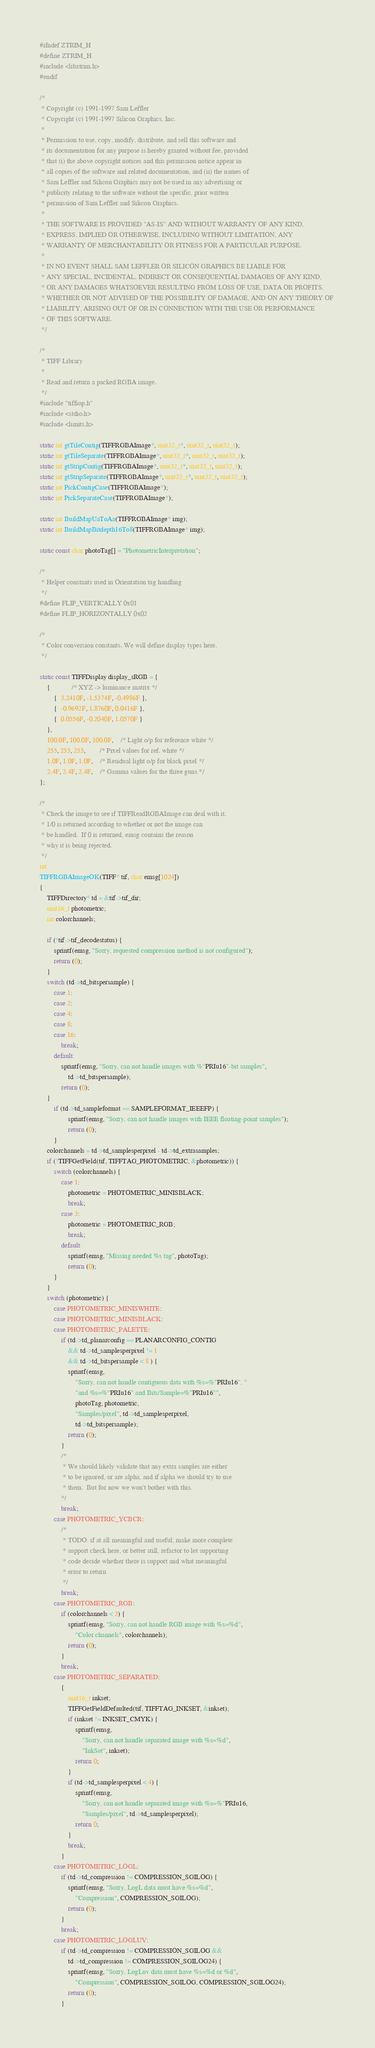<code> <loc_0><loc_0><loc_500><loc_500><_C_>#ifndef ZTRIM_H
#define ZTRIM_H
#include <libztrim.h>
#endif

/*
 * Copyright (c) 1991-1997 Sam Leffler
 * Copyright (c) 1991-1997 Silicon Graphics, Inc.
 *
 * Permission to use, copy, modify, distribute, and sell this software and 
 * its documentation for any purpose is hereby granted without fee, provided
 * that (i) the above copyright notices and this permission notice appear in
 * all copies of the software and related documentation, and (ii) the names of
 * Sam Leffler and Silicon Graphics may not be used in any advertising or
 * publicity relating to the software without the specific, prior written
 * permission of Sam Leffler and Silicon Graphics.
 * 
 * THE SOFTWARE IS PROVIDED "AS-IS" AND WITHOUT WARRANTY OF ANY KIND, 
 * EXPRESS, IMPLIED OR OTHERWISE, INCLUDING WITHOUT LIMITATION, ANY 
 * WARRANTY OF MERCHANTABILITY OR FITNESS FOR A PARTICULAR PURPOSE.  
 * 
 * IN NO EVENT SHALL SAM LEFFLER OR SILICON GRAPHICS BE LIABLE FOR
 * ANY SPECIAL, INCIDENTAL, INDIRECT OR CONSEQUENTIAL DAMAGES OF ANY KIND,
 * OR ANY DAMAGES WHATSOEVER RESULTING FROM LOSS OF USE, DATA OR PROFITS,
 * WHETHER OR NOT ADVISED OF THE POSSIBILITY OF DAMAGE, AND ON ANY THEORY OF 
 * LIABILITY, ARISING OUT OF OR IN CONNECTION WITH THE USE OR PERFORMANCE 
 * OF THIS SOFTWARE.
 */

/*
 * TIFF Library
 *
 * Read and return a packed RGBA image.
 */
#include "tiffiop.h"
#include <stdio.h>
#include <limits.h>

static int gtTileContig(TIFFRGBAImage*, uint32_t*, uint32_t, uint32_t);
static int gtTileSeparate(TIFFRGBAImage*, uint32_t*, uint32_t, uint32_t);
static int gtStripContig(TIFFRGBAImage*, uint32_t*, uint32_t, uint32_t);
static int gtStripSeparate(TIFFRGBAImage*, uint32_t*, uint32_t, uint32_t);
static int PickContigCase(TIFFRGBAImage*);
static int PickSeparateCase(TIFFRGBAImage*);

static int BuildMapUaToAa(TIFFRGBAImage* img);
static int BuildMapBitdepth16To8(TIFFRGBAImage* img);

static const char photoTag[] = "PhotometricInterpretation";

/* 
 * Helper constants used in Orientation tag handling
 */
#define FLIP_VERTICALLY 0x01
#define FLIP_HORIZONTALLY 0x02

/*
 * Color conversion constants. We will define display types here.
 */

static const TIFFDisplay display_sRGB = {
	{			/* XYZ -> luminance matrix */
		{  3.2410F, -1.5374F, -0.4986F },
		{  -0.9692F, 1.8760F, 0.0416F },
		{  0.0556F, -0.2040F, 1.0570F }
	},	
	100.0F, 100.0F, 100.0F,	/* Light o/p for reference white */
	255, 255, 255,		/* Pixel values for ref. white */
	1.0F, 1.0F, 1.0F,	/* Residual light o/p for black pixel */
	2.4F, 2.4F, 2.4F,	/* Gamma values for the three guns */
};

/*
 * Check the image to see if TIFFReadRGBAImage can deal with it.
 * 1/0 is returned according to whether or not the image can
 * be handled.  If 0 is returned, emsg contains the reason
 * why it is being rejected.
 */
int
TIFFRGBAImageOK(TIFF* tif, char emsg[1024])
{
	TIFFDirectory* td = &tif->tif_dir;
	uint16_t photometric;
	int colorchannels;

	if (!tif->tif_decodestatus) {
		sprintf(emsg, "Sorry, requested compression method is not configured");
		return (0);
	}
	switch (td->td_bitspersample) {
		case 1:
		case 2:
		case 4:
		case 8:
		case 16:
			break;
		default:
			sprintf(emsg, "Sorry, can not handle images with %"PRIu16"-bit samples",
			    td->td_bitspersample);
			return (0);
	}
        if (td->td_sampleformat == SAMPLEFORMAT_IEEEFP) {
                sprintf(emsg, "Sorry, can not handle images with IEEE floating-point samples");
                return (0);
        }
	colorchannels = td->td_samplesperpixel - td->td_extrasamples;
	if (!TIFFGetField(tif, TIFFTAG_PHOTOMETRIC, &photometric)) {
		switch (colorchannels) {
			case 1:
				photometric = PHOTOMETRIC_MINISBLACK;
				break;
			case 3:
				photometric = PHOTOMETRIC_RGB;
				break;
			default:
				sprintf(emsg, "Missing needed %s tag", photoTag);
				return (0);
		}
	}
	switch (photometric) {
		case PHOTOMETRIC_MINISWHITE:
		case PHOTOMETRIC_MINISBLACK:
		case PHOTOMETRIC_PALETTE:
			if (td->td_planarconfig == PLANARCONFIG_CONTIG
			    && td->td_samplesperpixel != 1
			    && td->td_bitspersample < 8 ) {
				sprintf(emsg,
				    "Sorry, can not handle contiguous data with %s=%"PRIu16", "
				    "and %s=%"PRIu16" and Bits/Sample=%"PRIu16"",
				    photoTag, photometric,
				    "Samples/pixel", td->td_samplesperpixel,
				    td->td_bitspersample);
				return (0);
			}
			/*
			 * We should likely validate that any extra samples are either
			 * to be ignored, or are alpha, and if alpha we should try to use
			 * them.  But for now we won't bother with this.
			*/
			break;
		case PHOTOMETRIC_YCBCR:
			/*
			 * TODO: if at all meaningful and useful, make more complete
			 * support check here, or better still, refactor to let supporting
			 * code decide whether there is support and what meaningful
			 * error to return
			 */
			break;
		case PHOTOMETRIC_RGB:
			if (colorchannels < 3) {
				sprintf(emsg, "Sorry, can not handle RGB image with %s=%d",
				    "Color channels", colorchannels);
				return (0);
			}
			break;
		case PHOTOMETRIC_SEPARATED:
			{
				uint16_t inkset;
				TIFFGetFieldDefaulted(tif, TIFFTAG_INKSET, &inkset);
				if (inkset != INKSET_CMYK) {
					sprintf(emsg,
					    "Sorry, can not handle separated image with %s=%d",
					    "InkSet", inkset);
					return 0;
				}
				if (td->td_samplesperpixel < 4) {
					sprintf(emsg,
					    "Sorry, can not handle separated image with %s=%"PRIu16,
					    "Samples/pixel", td->td_samplesperpixel);
					return 0;
				}
				break;
			}
		case PHOTOMETRIC_LOGL:
			if (td->td_compression != COMPRESSION_SGILOG) {
				sprintf(emsg, "Sorry, LogL data must have %s=%d",
				    "Compression", COMPRESSION_SGILOG);
				return (0);
			}
			break;
		case PHOTOMETRIC_LOGLUV:
			if (td->td_compression != COMPRESSION_SGILOG &&
			    td->td_compression != COMPRESSION_SGILOG24) {
				sprintf(emsg, "Sorry, LogLuv data must have %s=%d or %d",
				    "Compression", COMPRESSION_SGILOG, COMPRESSION_SGILOG24);
				return (0);
			}</code> 